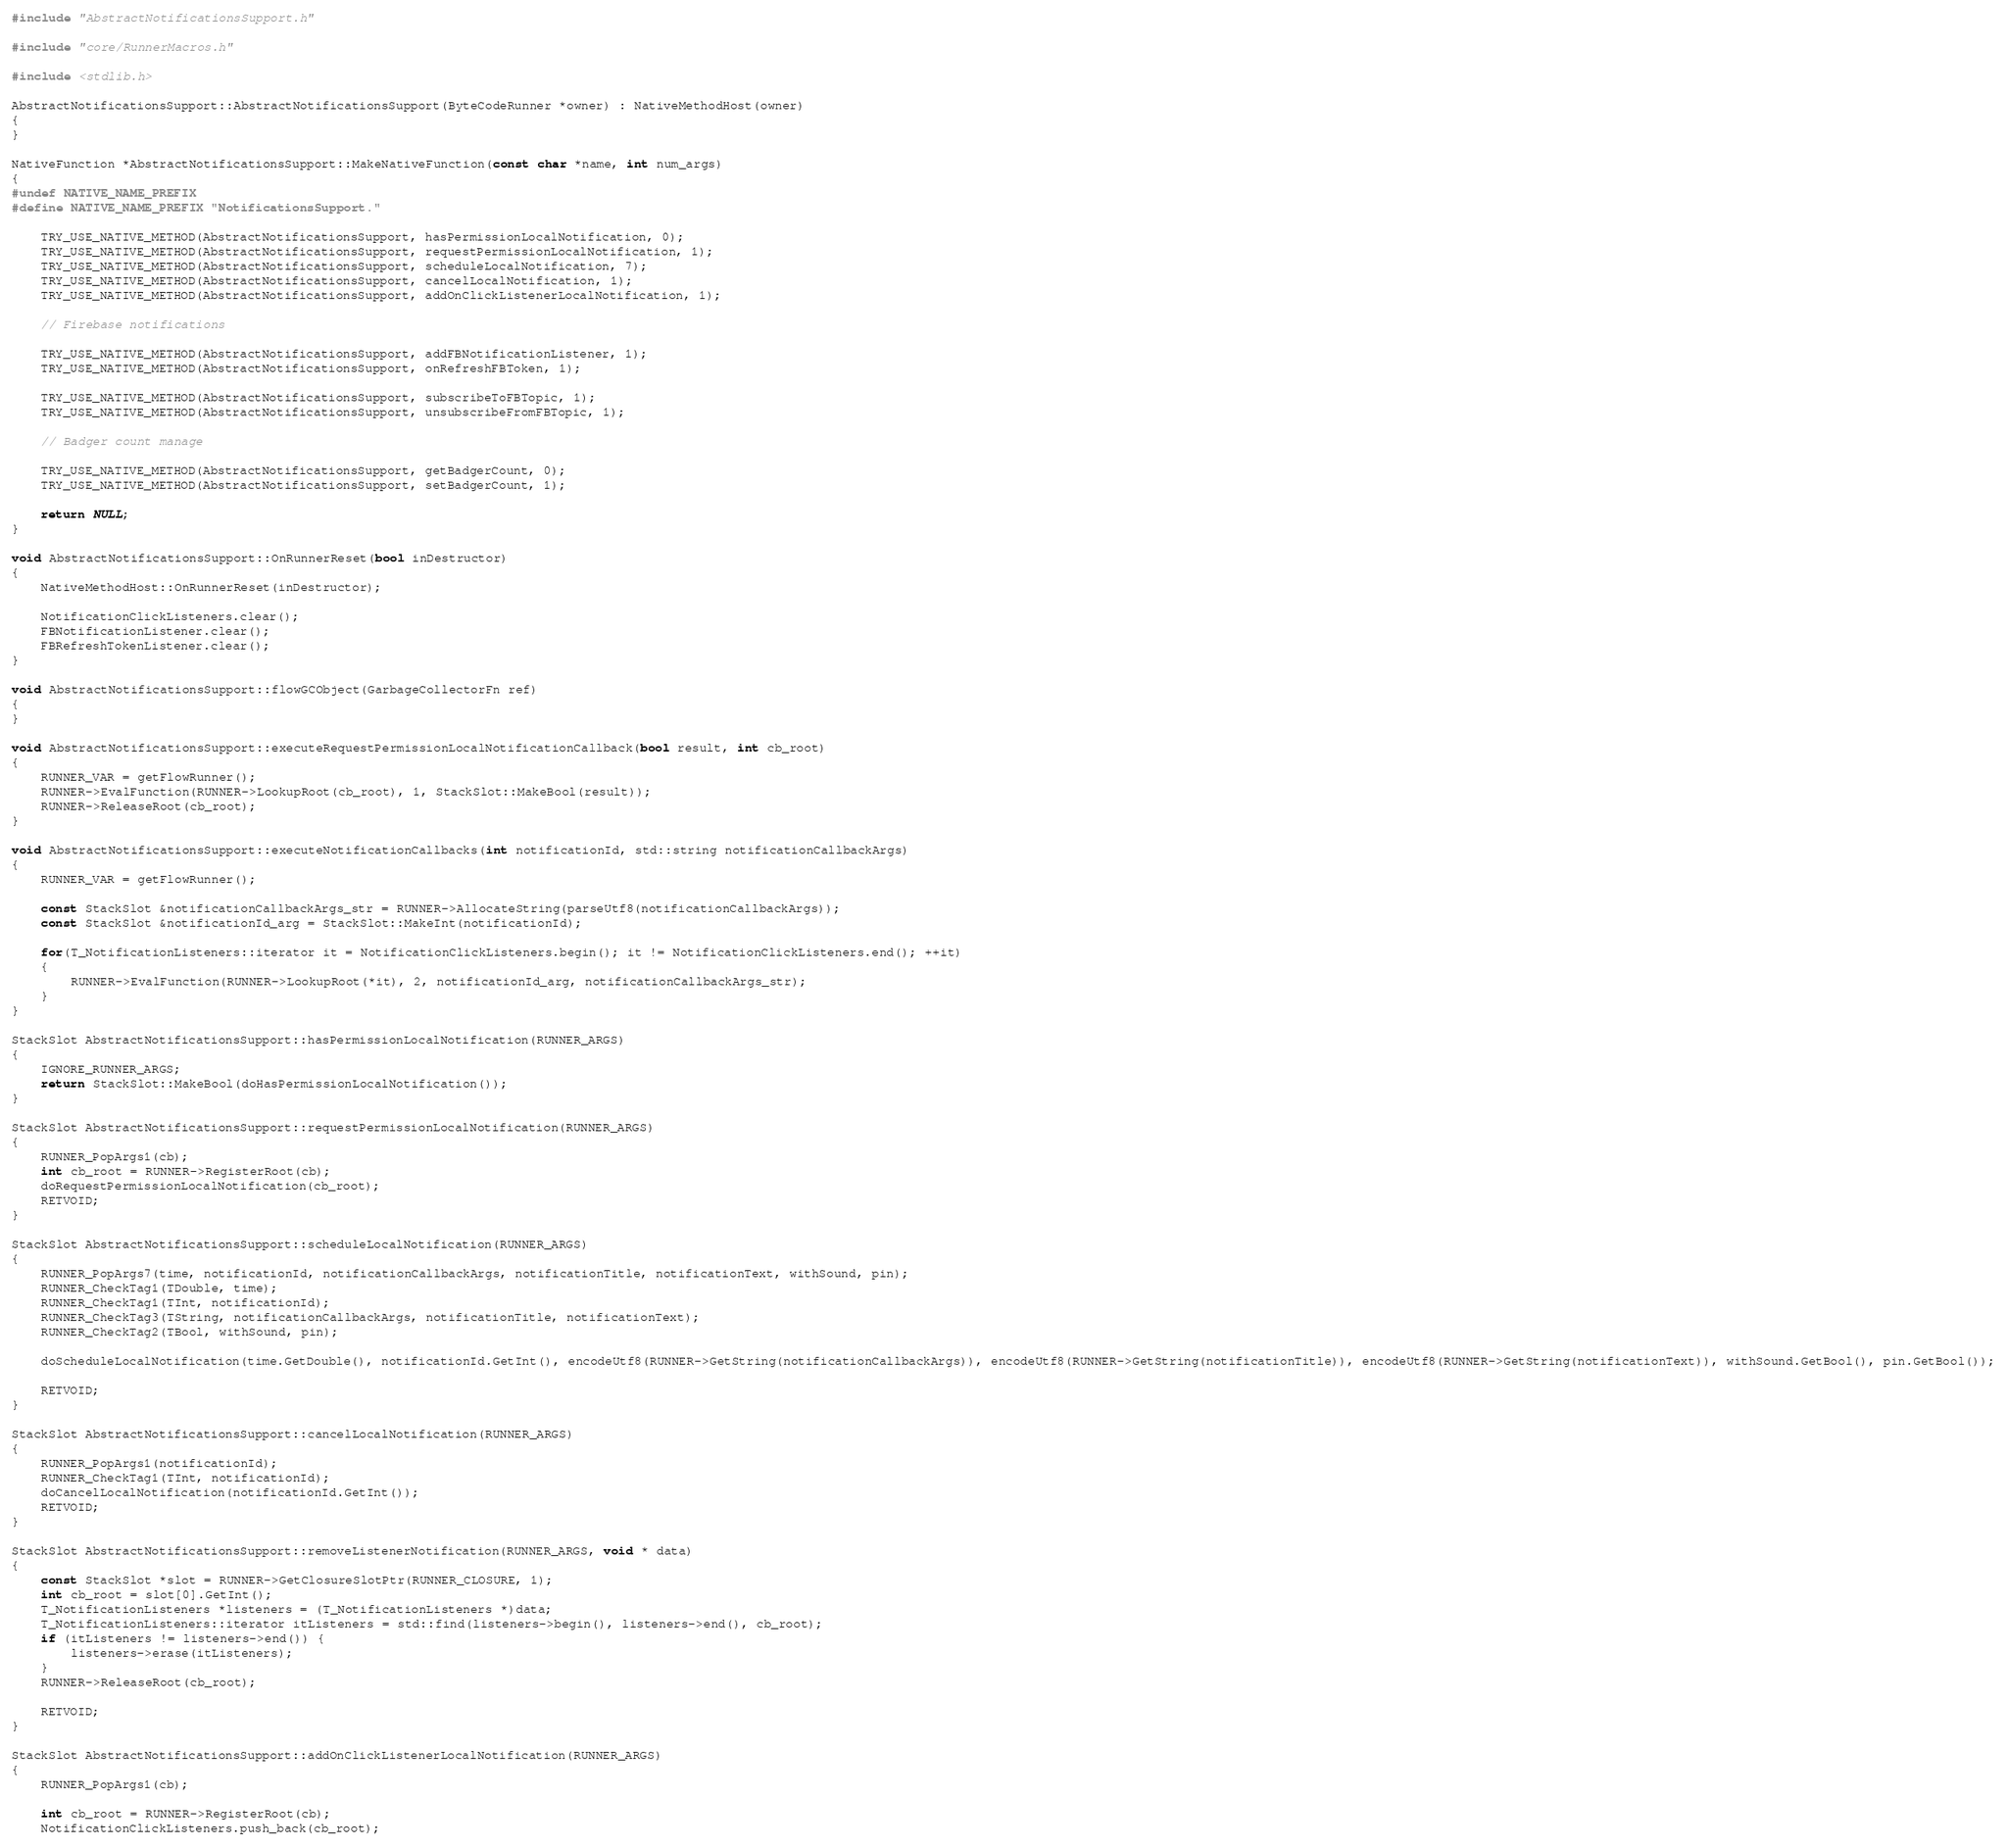<code> <loc_0><loc_0><loc_500><loc_500><_C++_>#include "AbstractNotificationsSupport.h"

#include "core/RunnerMacros.h"

#include <stdlib.h>

AbstractNotificationsSupport::AbstractNotificationsSupport(ByteCodeRunner *owner) : NativeMethodHost(owner)
{
}

NativeFunction *AbstractNotificationsSupport::MakeNativeFunction(const char *name, int num_args)
{
#undef NATIVE_NAME_PREFIX
#define NATIVE_NAME_PREFIX "NotificationsSupport."

    TRY_USE_NATIVE_METHOD(AbstractNotificationsSupport, hasPermissionLocalNotification, 0);
    TRY_USE_NATIVE_METHOD(AbstractNotificationsSupport, requestPermissionLocalNotification, 1);
    TRY_USE_NATIVE_METHOD(AbstractNotificationsSupport, scheduleLocalNotification, 7);
    TRY_USE_NATIVE_METHOD(AbstractNotificationsSupport, cancelLocalNotification, 1);
    TRY_USE_NATIVE_METHOD(AbstractNotificationsSupport, addOnClickListenerLocalNotification, 1);

    // Firebase notifications

    TRY_USE_NATIVE_METHOD(AbstractNotificationsSupport, addFBNotificationListener, 1);
    TRY_USE_NATIVE_METHOD(AbstractNotificationsSupport, onRefreshFBToken, 1);

    TRY_USE_NATIVE_METHOD(AbstractNotificationsSupport, subscribeToFBTopic, 1);
    TRY_USE_NATIVE_METHOD(AbstractNotificationsSupport, unsubscribeFromFBTopic, 1);
    
    // Badger count manage
    
    TRY_USE_NATIVE_METHOD(AbstractNotificationsSupport, getBadgerCount, 0);
    TRY_USE_NATIVE_METHOD(AbstractNotificationsSupport, setBadgerCount, 1);

    return NULL;
}

void AbstractNotificationsSupport::OnRunnerReset(bool inDestructor)
{
    NativeMethodHost::OnRunnerReset(inDestructor);

    NotificationClickListeners.clear();
    FBNotificationListener.clear();
    FBRefreshTokenListener.clear();
}

void AbstractNotificationsSupport::flowGCObject(GarbageCollectorFn ref)
{
}

void AbstractNotificationsSupport::executeRequestPermissionLocalNotificationCallback(bool result, int cb_root)
{
    RUNNER_VAR = getFlowRunner();
    RUNNER->EvalFunction(RUNNER->LookupRoot(cb_root), 1, StackSlot::MakeBool(result));
    RUNNER->ReleaseRoot(cb_root);
}

void AbstractNotificationsSupport::executeNotificationCallbacks(int notificationId, std::string notificationCallbackArgs)
{
    RUNNER_VAR = getFlowRunner();

    const StackSlot &notificationCallbackArgs_str = RUNNER->AllocateString(parseUtf8(notificationCallbackArgs));
    const StackSlot &notificationId_arg = StackSlot::MakeInt(notificationId);

    for(T_NotificationListeners::iterator it = NotificationClickListeners.begin(); it != NotificationClickListeners.end(); ++it)
    {
        RUNNER->EvalFunction(RUNNER->LookupRoot(*it), 2, notificationId_arg, notificationCallbackArgs_str);
    }
}

StackSlot AbstractNotificationsSupport::hasPermissionLocalNotification(RUNNER_ARGS)
{
    IGNORE_RUNNER_ARGS;
    return StackSlot::MakeBool(doHasPermissionLocalNotification());
}

StackSlot AbstractNotificationsSupport::requestPermissionLocalNotification(RUNNER_ARGS)
{
    RUNNER_PopArgs1(cb);
    int cb_root = RUNNER->RegisterRoot(cb);
    doRequestPermissionLocalNotification(cb_root);
    RETVOID;
}

StackSlot AbstractNotificationsSupport::scheduleLocalNotification(RUNNER_ARGS)
{
    RUNNER_PopArgs7(time, notificationId, notificationCallbackArgs, notificationTitle, notificationText, withSound, pin);
    RUNNER_CheckTag1(TDouble, time);
    RUNNER_CheckTag1(TInt, notificationId);
    RUNNER_CheckTag3(TString, notificationCallbackArgs, notificationTitle, notificationText);
    RUNNER_CheckTag2(TBool, withSound, pin);

    doScheduleLocalNotification(time.GetDouble(), notificationId.GetInt(), encodeUtf8(RUNNER->GetString(notificationCallbackArgs)), encodeUtf8(RUNNER->GetString(notificationTitle)), encodeUtf8(RUNNER->GetString(notificationText)), withSound.GetBool(), pin.GetBool());

    RETVOID;
}

StackSlot AbstractNotificationsSupport::cancelLocalNotification(RUNNER_ARGS)
{
    RUNNER_PopArgs1(notificationId);
    RUNNER_CheckTag1(TInt, notificationId);
    doCancelLocalNotification(notificationId.GetInt());
    RETVOID;
}

StackSlot AbstractNotificationsSupport::removeListenerNotification(RUNNER_ARGS, void * data)
{
    const StackSlot *slot = RUNNER->GetClosureSlotPtr(RUNNER_CLOSURE, 1);
    int cb_root = slot[0].GetInt();
    T_NotificationListeners *listeners = (T_NotificationListeners *)data;
    T_NotificationListeners::iterator itListeners = std::find(listeners->begin(), listeners->end(), cb_root);
    if (itListeners != listeners->end()) {
        listeners->erase(itListeners);
    }
    RUNNER->ReleaseRoot(cb_root);

    RETVOID;
}

StackSlot AbstractNotificationsSupport::addOnClickListenerLocalNotification(RUNNER_ARGS)
{
    RUNNER_PopArgs1(cb);

    int cb_root = RUNNER->RegisterRoot(cb);
    NotificationClickListeners.push_back(cb_root);
</code> 